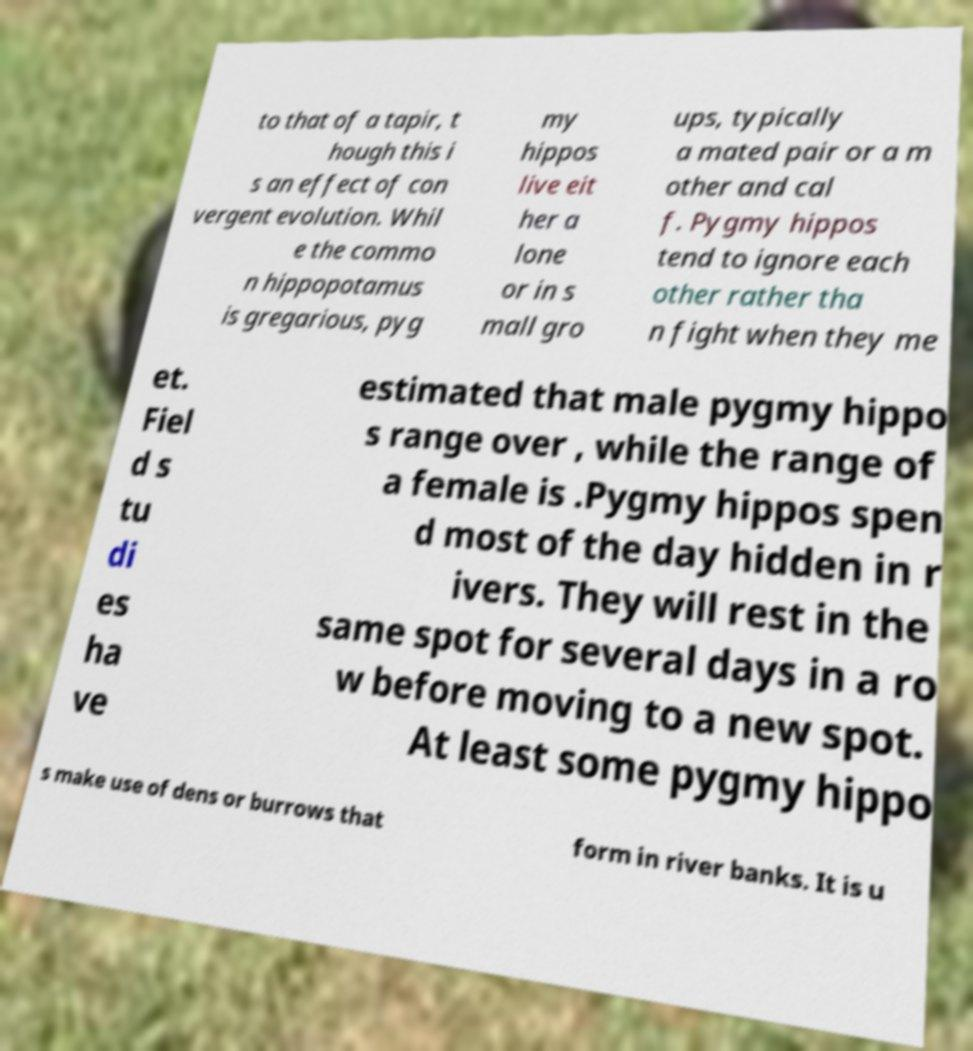Could you extract and type out the text from this image? to that of a tapir, t hough this i s an effect of con vergent evolution. Whil e the commo n hippopotamus is gregarious, pyg my hippos live eit her a lone or in s mall gro ups, typically a mated pair or a m other and cal f. Pygmy hippos tend to ignore each other rather tha n fight when they me et. Fiel d s tu di es ha ve estimated that male pygmy hippo s range over , while the range of a female is .Pygmy hippos spen d most of the day hidden in r ivers. They will rest in the same spot for several days in a ro w before moving to a new spot. At least some pygmy hippo s make use of dens or burrows that form in river banks. It is u 